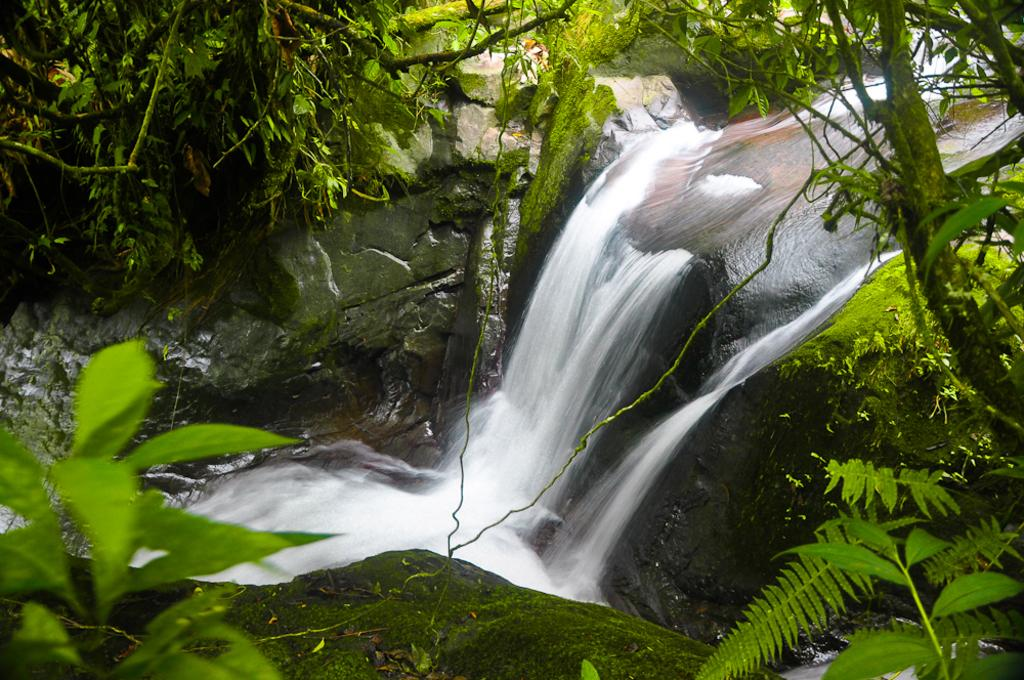What is the main feature in the center of the image? There is a waterfall in the center of the image. What types of vegetation can be seen in the image? There are plants, trees, and rocks in the foreground and background of the image. Can you describe the landscape in the image? The landscape features a waterfall, plants, trees, and rocks in the foreground and background. What type of meal is being prepared near the waterfall in the image? There is no meal being prepared in the image; it features a waterfall and surrounding landscape. 